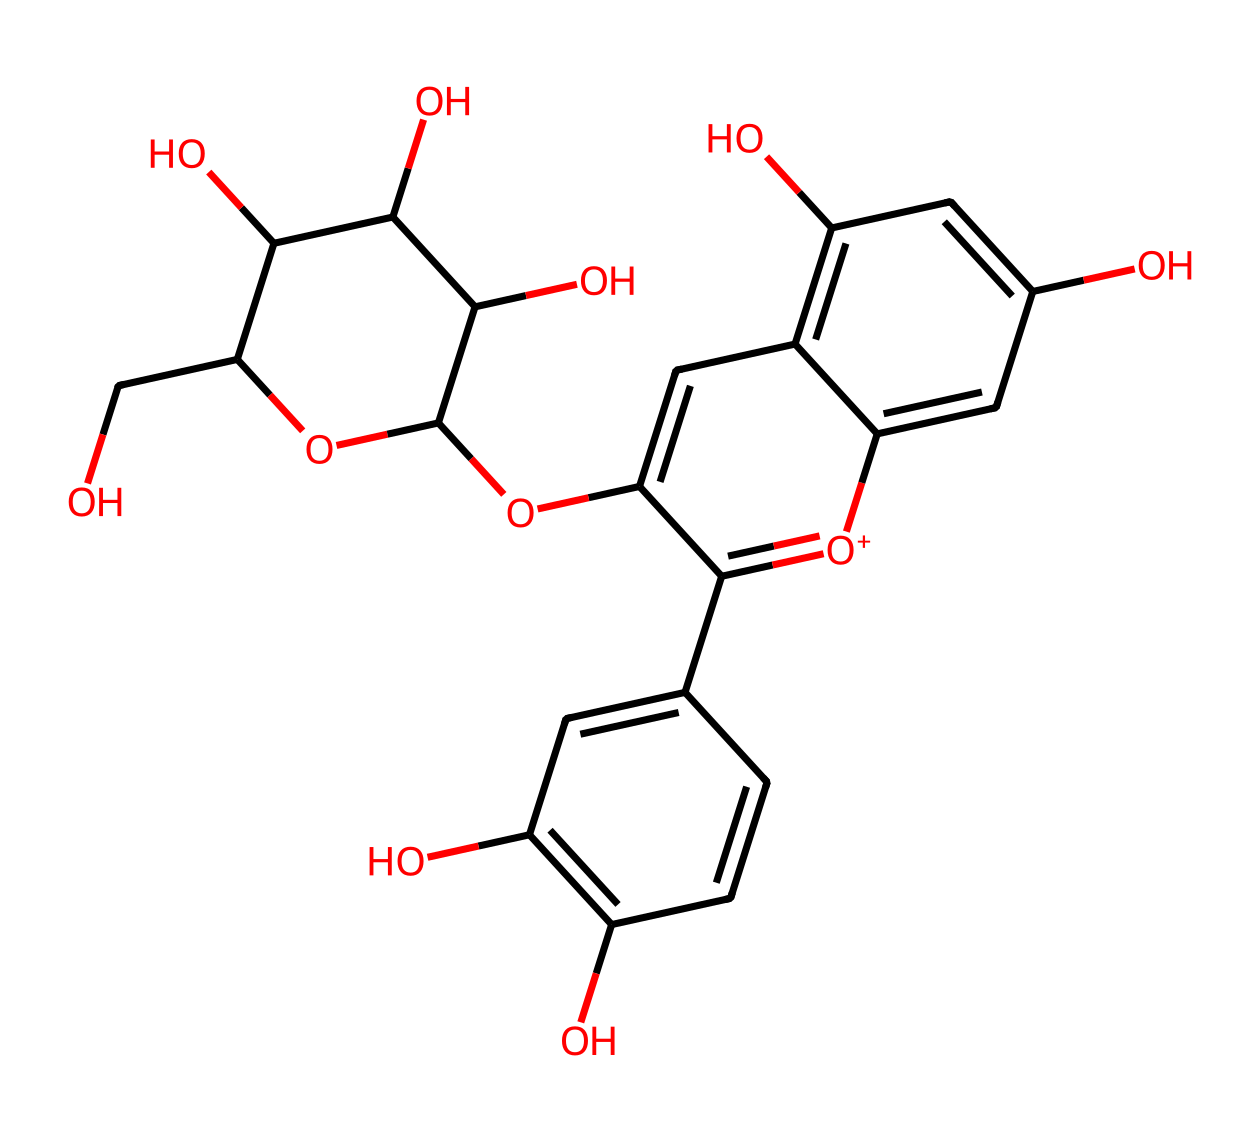what is the main functional group present in this structure? The structure contains multiple hydroxyl (–OH) groups, which are characteristic of phenolic compounds and contribute to its antioxidant properties. The presence of –OH groups indicates it's a phenolic compound, commonly found in antioxidants.
Answer: hydroxyl group how many aromatic rings can be identified in this chemical structure? By analyzing the chemical structure, we can see there are two distinct aromatic rings present. They can be identified by the alternating double bonds and the cyclic structure in the representation.
Answer: two what is the likely biological role of the antioxidants in this chemical? Given the presence of multiple hydroxyl groups and aromatic systems, these antioxidants can likely scavenge free radicals, which helps in reducing oxidative stress in biological systems. This is a common role of antioxidants.
Answer: free radical scavenging what type of antioxidant activity does this compound exhibit? The compound mainly exhibits radical scavenging activity due to its phenolic nature, where the hydroxyl groups can donate hydrogen atoms to stabilize free radicals. This specific activity is crucial in protecting cells from oxidative damage.
Answer: radical scavenging how many hydroxyl groups are present in this antioxidant structure? By counting the number of hydroxyl (–OH) groups in the chemical structure, we can determine there are six hydroxyl groups in total, which can enhance its antioxidant activity due to their ability to donate electrons.
Answer: six what is the significance of the methoxy group in this antioxidant? The methoxy group may enhance the lipophilicity of the antioxidant, allowing better penetration through cell membranes, thus increasing its bioavailability and efficacy in biological systems.
Answer: enhances bioavailability 